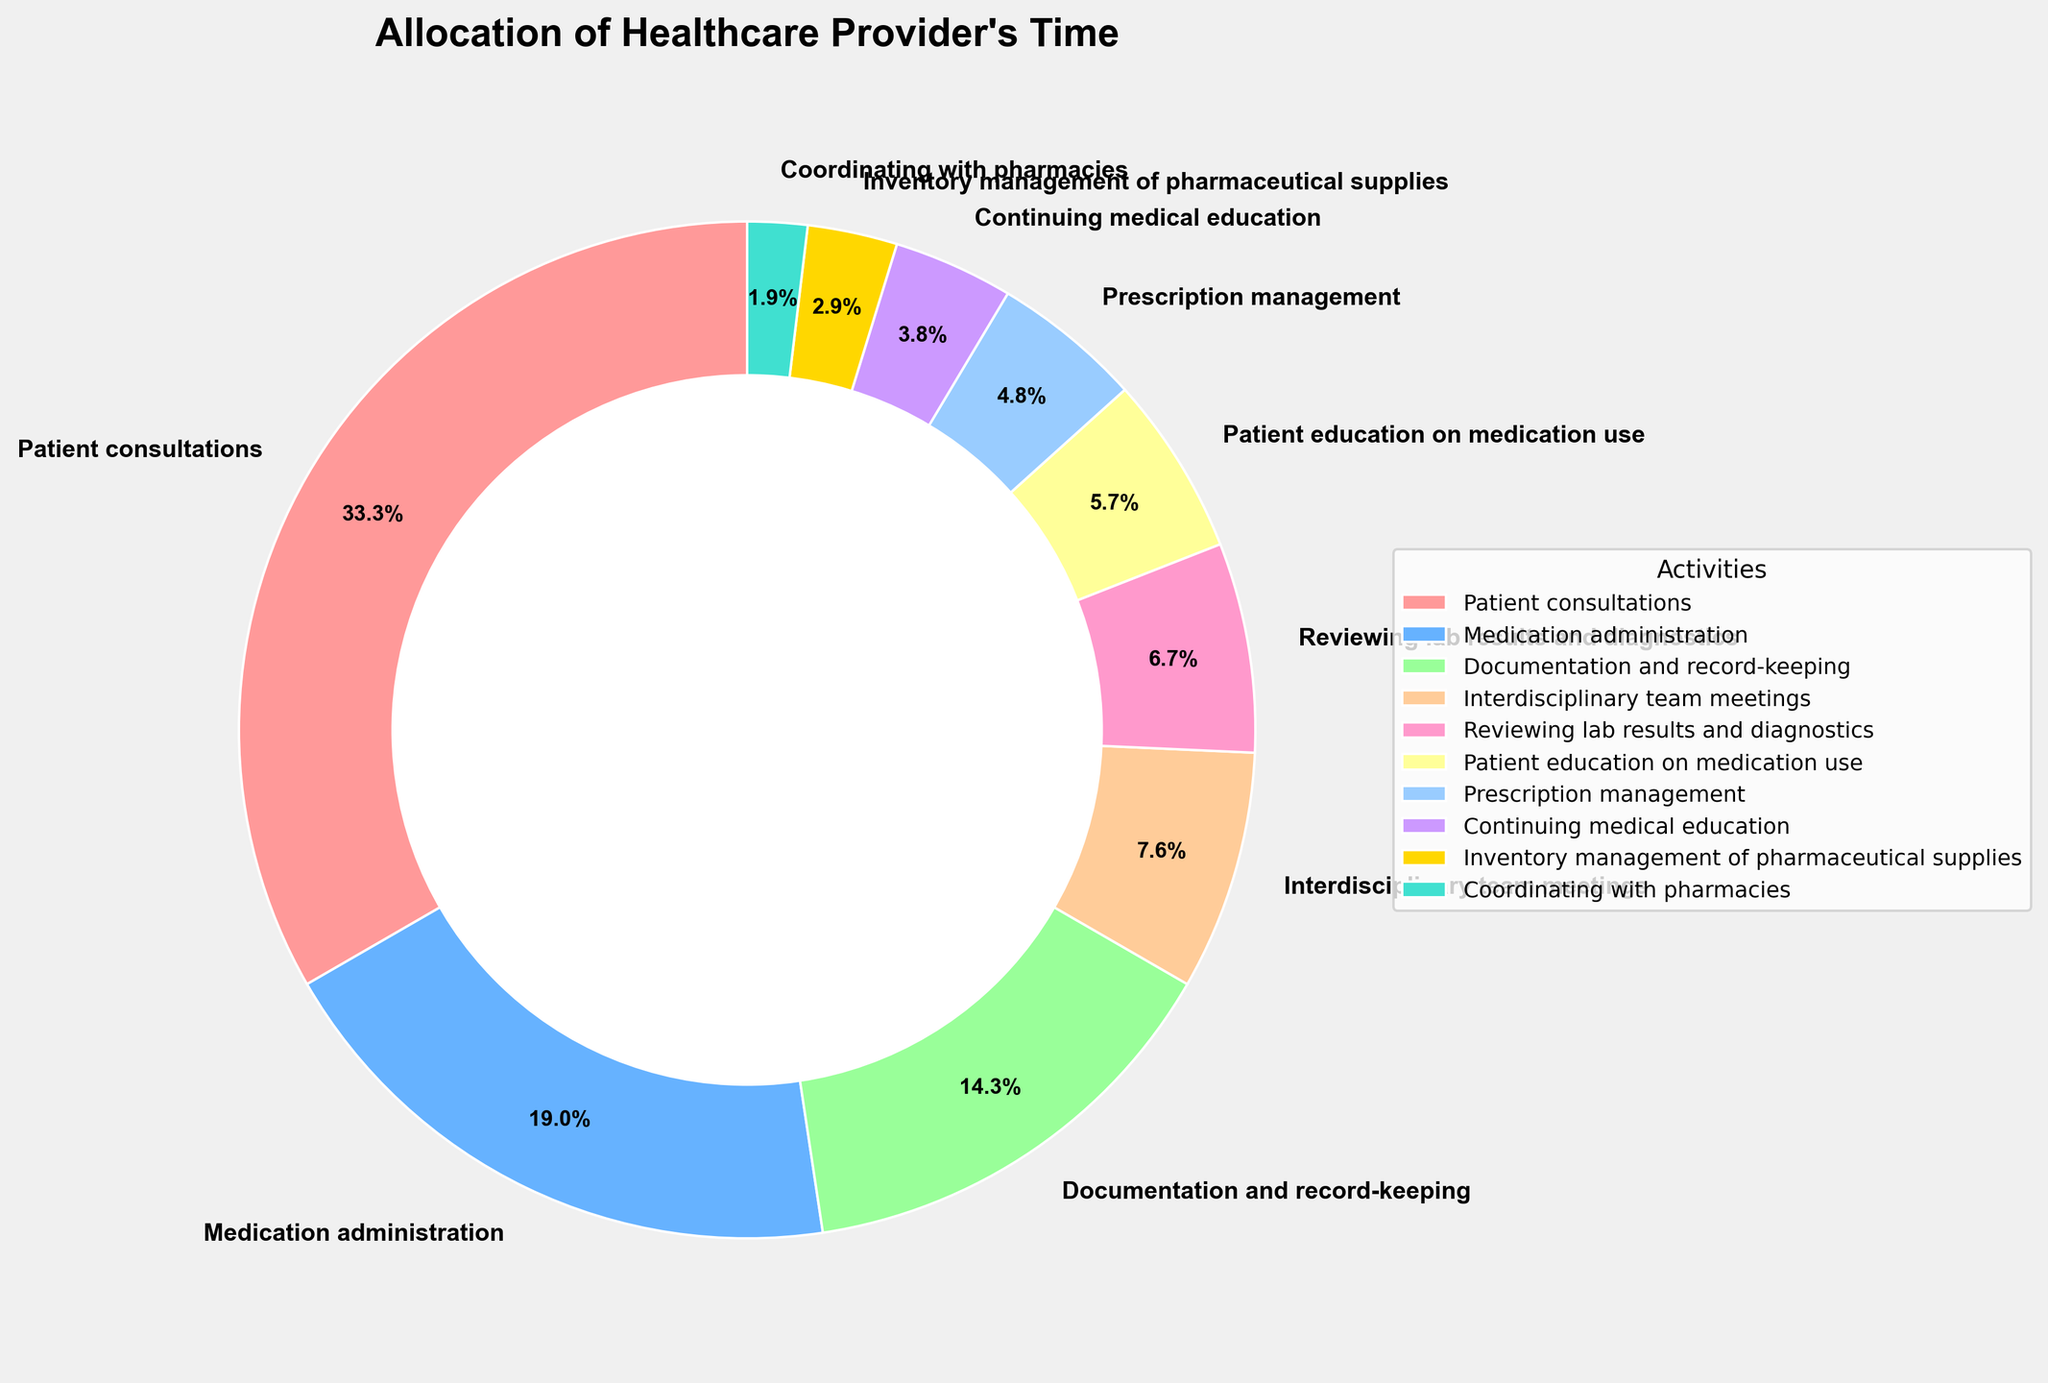What is the percentage of time spent on direct patient care activities, such as patient consultations and medication administration? Direct patient care activities include patient consultations and medication administration. The percentage for patient consultations is 35%, and for medication administration is 20%. Summing these gives 35% + 20% = 55%.
Answer: 55% Which activity takes up the least amount of the healthcare provider's time? We look for the smallest percentage value in the chart. The activity that occupies only 2% of the healthcare provider's time is coordinating with pharmacies.
Answer: Coordinating with pharmacies Is more time spent on interdisciplinary team meetings or patient education on medication use? Comparing the percentages, time spent on interdisciplinary team meetings is 8%, while time spent on patient education on medication use is 6%. Since 8% > 6%, more time is spent on interdisciplinary team meetings.
Answer: Interdisciplinary team meetings How much more time is spent on documentation and record-keeping compared to inventory management of pharmaceutical supplies? The time allocated to documentation and record-keeping is 15%, and for inventory management of pharmaceutical supplies, it is 3%. The difference is 15% - 3% = 12%.
Answer: 12% What percentage of the healthcare provider's time is allocated to activities other than patient consultations, medication administration, and documentation and record-keeping? The percentages for patient consultations, medication administration, and documentation and record-keeping are 35%, 20%, and 15%, respectively. The sum of these is 35% + 20% + 15% = 70%. Therefore, the percentage of time allocated to other activities is 100% - 70% = 30%.
Answer: 30% If continuing medical education and prescription management are combined, what percentage of time do they occupy? The percentage for continuing medical education is 4%, and for prescription management, it's 5%. Combining these gives 4% + 5% = 9%.
Answer: 9% Compare the amount of time spent on reviewing lab results and diagnostics with the time spent on patient education on medication use. Which one is higher and by how much? The percentage for reviewing lab results and diagnostics is 7%, and for patient education on medication use, it is 6%. Since 7% > 6%, reviewing lab results and diagnostics takes 1% more time than patient education on medication use.
Answer: Reviewing lab results and diagnostics by 1% What proportion of time is spent on interdisciplinary team meetings, reviewing lab results and diagnostics, and patient education combined? The time percentages are 8% for interdisciplinary team meetings, 7% for reviewing lab results and diagnostics, and 6% for patient education on medication use. Adding these gives 8% + 7% + 6% = 21%.
Answer: 21% Which activity takes up more than four times the amount of time spent on inventory management of pharmaceutical supplies? Inventory management of pharmaceutical supplies takes 3% of the time. An activity that takes up more than four times this amount would require >3% * 4 = 12%. Patient consultations (35%) and medication administration (20%) both meet this criterion.
Answer: Patient consultations and medication administration 